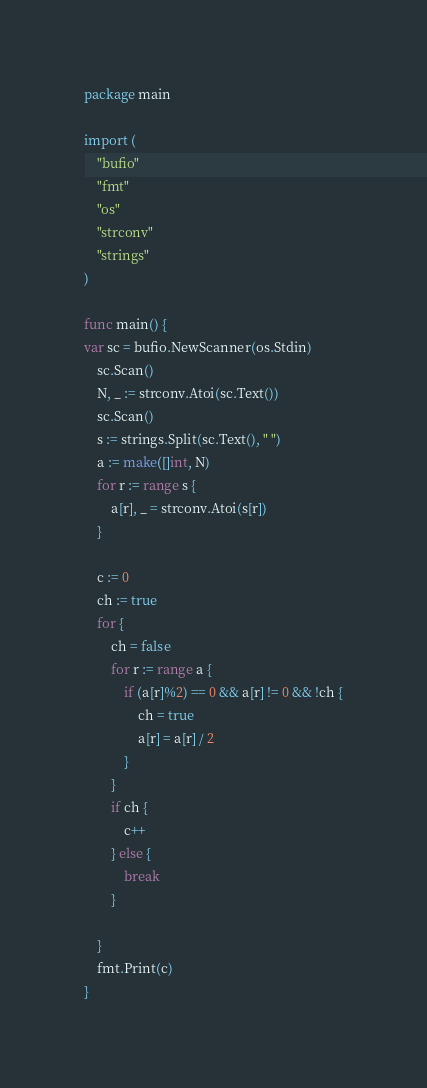Convert code to text. <code><loc_0><loc_0><loc_500><loc_500><_Go_>package main

import (
	"bufio"
	"fmt"
	"os"
	"strconv"
	"strings"
)

func main() {
var sc = bufio.NewScanner(os.Stdin)
	sc.Scan()
	N, _ := strconv.Atoi(sc.Text())
	sc.Scan()
	s := strings.Split(sc.Text(), " ")
	a := make([]int, N)
	for r := range s {
		a[r], _ = strconv.Atoi(s[r])
	}

	c := 0
	ch := true
	for {
		ch = false
		for r := range a {
			if (a[r]%2) == 0 && a[r] != 0 && !ch {
				ch = true
				a[r] = a[r] / 2
			}
		}
		if ch {
			c++
		} else {
			break
		}

	}
	fmt.Print(c)
}
</code> 